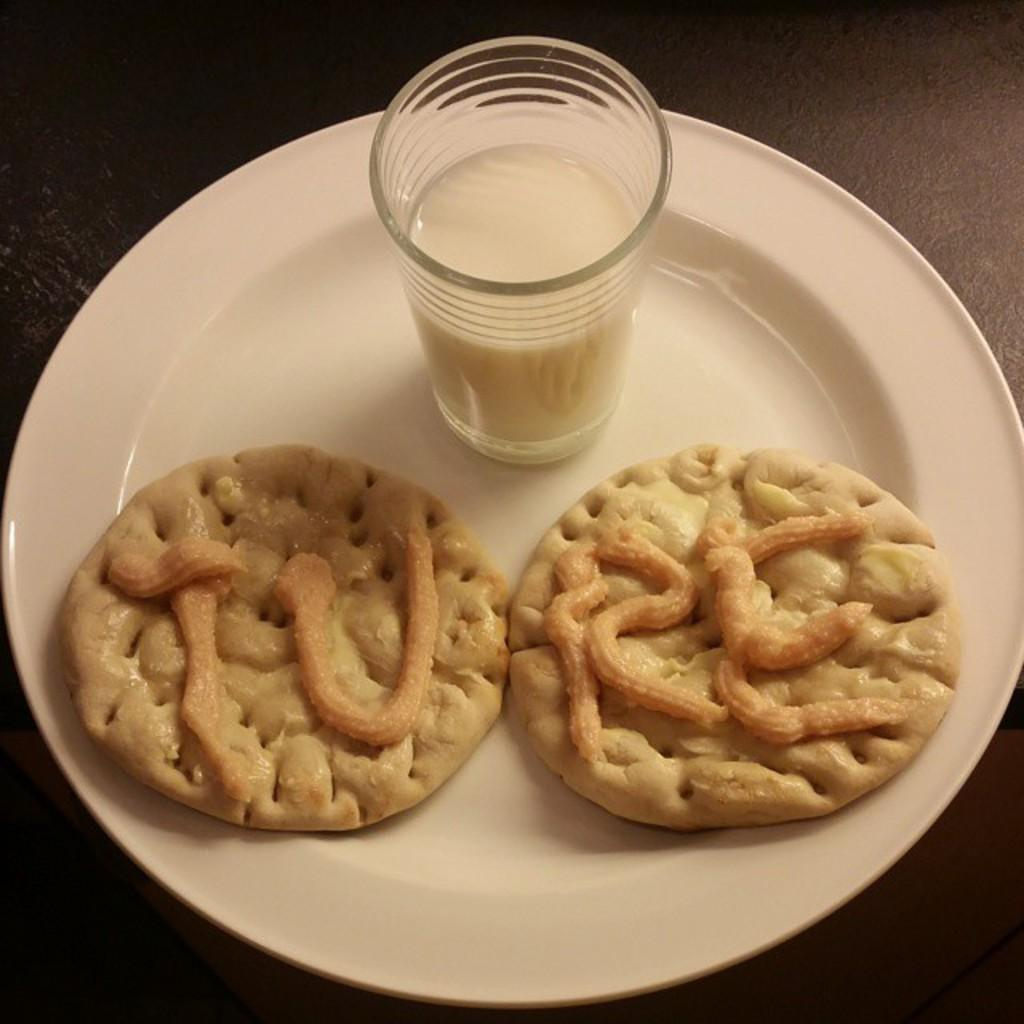What piece of furniture is present in the image? There is a table in the image. What is placed on the table? There is a plate on the table. What food items are on the plate? There are two cookies on the plate. What beverage is visible in the image? There is a glass of milk on the plate. What type of crayon can be seen on the sidewalk in the image? There is no crayon or sidewalk present in the image; it features a table, plate, cookies, and a glass of milk. 